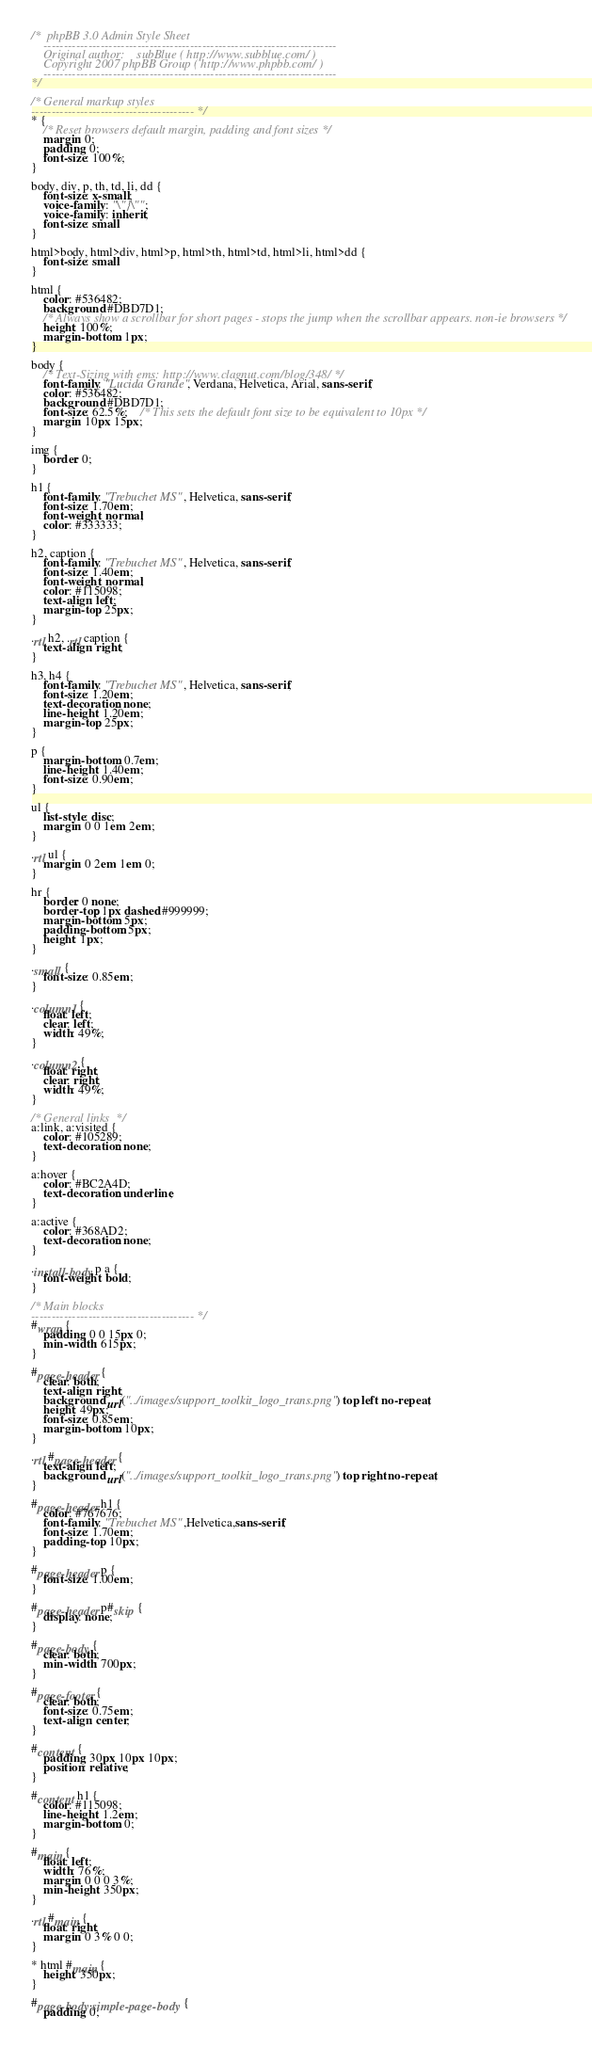Convert code to text. <code><loc_0><loc_0><loc_500><loc_500><_CSS_>/*  phpBB 3.0 Admin Style Sheet
	------------------------------------------------------------------------
	Original author:	subBlue ( http://www.subblue.com/ )
	Copyright 2007 phpBB Group ( http://www.phpbb.com/ )
	------------------------------------------------------------------------
*/

/* General markup styles
---------------------------------------- */
* {
	/* Reset browsers default margin, padding and font sizes */
	margin: 0;
	padding: 0;
	font-size: 100%;
}

body, div, p, th, td, li, dd {
	font-size: x-small;
	voice-family: "\"}\"";
	voice-family: inherit;
	font-size: small
}

html>body, html>div, html>p, html>th, html>td, html>li, html>dd {
	font-size: small
}

html {
	color: #536482;
	background: #DBD7D1;
	/* Always show a scrollbar for short pages - stops the jump when the scrollbar appears. non-ie browsers */
	height: 100%;
	margin-bottom: 1px;
}

body {
	/* Text-Sizing with ems: http://www.clagnut.com/blog/348/ */
	font-family: "Lucida Grande", Verdana, Helvetica, Arial, sans-serif;
	color: #536482;
	background: #DBD7D1;
	font-size: 62.5%;	/* This sets the default font size to be equivalent to 10px */
	margin: 10px 15px;
}

img {
	border: 0;
}

h1 {
	font-family: "Trebuchet MS", Helvetica, sans-serif;
	font-size: 1.70em;
	font-weight: normal;
	color: #333333;
}

h2, caption {
	font-family: "Trebuchet MS", Helvetica, sans-serif;
	font-size: 1.40em;
	font-weight: normal;
	color: #115098;
	text-align: left;
	margin-top: 25px;
}

.rtl h2, .rtl caption {
	text-align: right;
}

h3, h4 {
	font-family: "Trebuchet MS", Helvetica, sans-serif;
	font-size: 1.20em;
	text-decoration: none;
	line-height: 1.20em;
	margin-top: 25px;
}

p {
	margin-bottom: 0.7em;
	line-height: 1.40em;
	font-size: 0.90em;
}

ul {
	list-style: disc;
	margin: 0 0 1em 2em;
}

.rtl ul {
	margin: 0 2em 1em 0;
}

hr {
	border: 0 none;
	border-top: 1px dashed #999999;
	margin-bottom: 5px;
	padding-bottom: 5px;
	height: 1px;
}

.small {
	font-size: 0.85em;
}

.column1 {
	float: left;
	clear: left;
	width: 49%;
}

.column2 {
	float: right;
	clear: right;
	width: 49%;
}

/* General links  */
a:link, a:visited {
	color: #105289;
	text-decoration: none;
}

a:hover {
	color: #BC2A4D;
	text-decoration: underline;
}

a:active {
	color: #368AD2;
	text-decoration: none;
}

.install-body p a {
	font-weight: bold;
}

/* Main blocks
---------------------------------------- */
#wrap {
	padding: 0 0 15px 0;
	min-width: 615px;
}

#page-header {
	clear: both;
	text-align: right;
	background: url("../images/support_toolkit_logo_trans.png") top left no-repeat;
	height: 49px;
	font-size: 0.85em;
	margin-bottom: 10px;
}

.rtl #page-header {
	text-align: left;
	background: url("../images/support_toolkit_logo_trans.png") top right no-repeat;
}

#page-header h1 {
	color: #767676;
	font-family: "Trebuchet MS",Helvetica,sans-serif;
	font-size: 1.70em;
	padding-top: 10px;
}

#page-header p {
	font-size: 1.00em;
}

#page-header p#skip {
	display: none;
}

#page-body {
	clear: both;
	min-width: 700px;
}

#page-footer {
	clear: both;
	font-size: 0.75em;
	text-align: center;
}

#content {
	padding: 30px 10px 10px;
	position: relative;
}

#content h1 {
	color: #115098;
	line-height: 1.2em;
	margin-bottom: 0;
}

#main {
	float: left;
	width: 76%;
	margin: 0 0 0 3%;
	min-height: 350px;
}

.rtl #main {
	float: right;
	margin: 0 3% 0 0;
}

* html #main {
	height: 350px;
}

#page-body.simple-page-body {
	padding: 0;</code> 